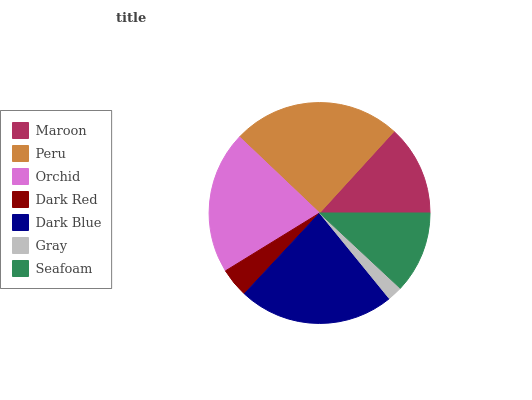Is Gray the minimum?
Answer yes or no. Yes. Is Peru the maximum?
Answer yes or no. Yes. Is Orchid the minimum?
Answer yes or no. No. Is Orchid the maximum?
Answer yes or no. No. Is Peru greater than Orchid?
Answer yes or no. Yes. Is Orchid less than Peru?
Answer yes or no. Yes. Is Orchid greater than Peru?
Answer yes or no. No. Is Peru less than Orchid?
Answer yes or no. No. Is Maroon the high median?
Answer yes or no. Yes. Is Maroon the low median?
Answer yes or no. Yes. Is Orchid the high median?
Answer yes or no. No. Is Dark Red the low median?
Answer yes or no. No. 